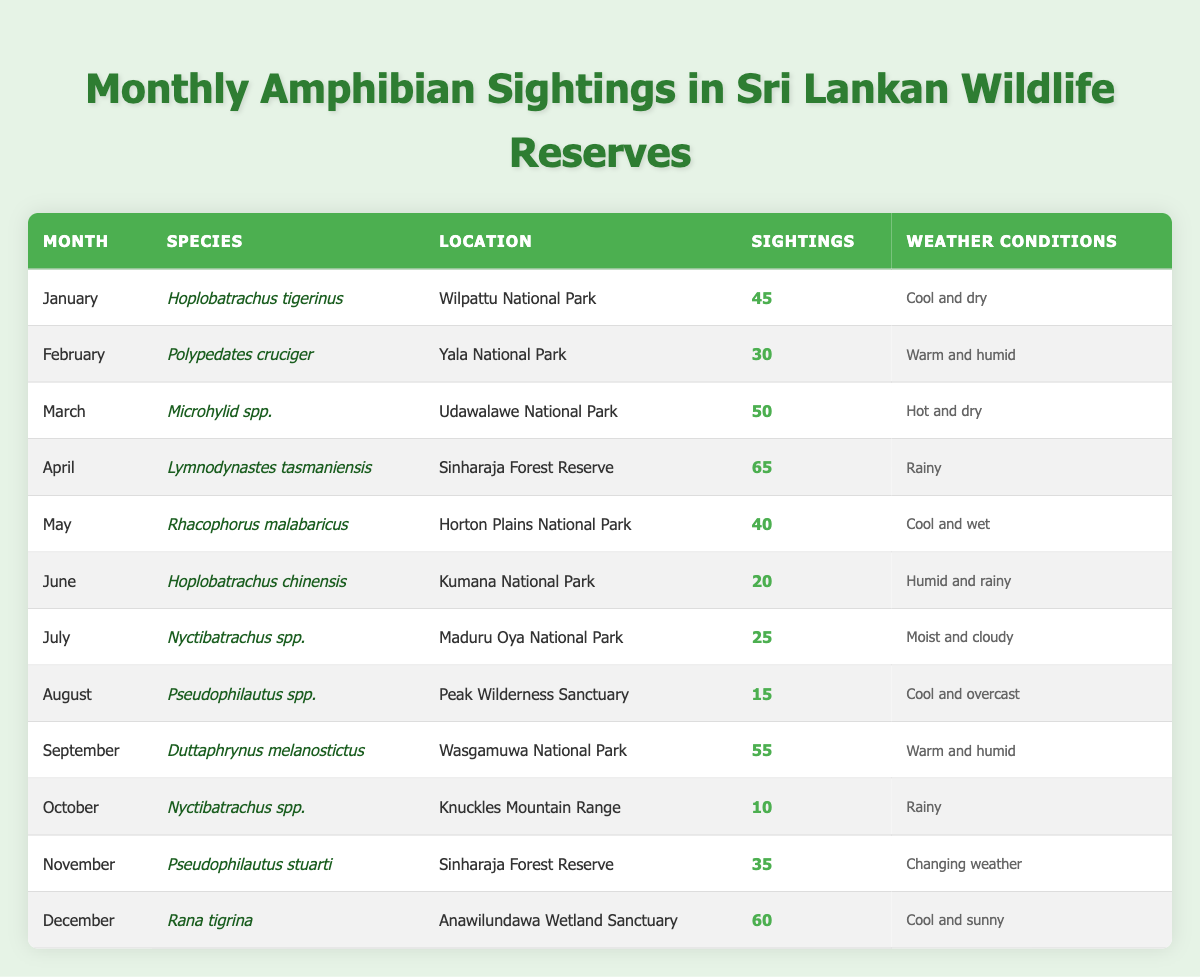What species had the highest number of sightings in April? In April, the species listed is Lymnodynastes tasmaniensis, and the sightings count is 65, which is the highest compared to other months.
Answer: Lymnodynastes tasmaniensis How many amphibians were sighted in November compared to December? In November, there were 35 sightings, while in December, there were 60 sightings. The difference is 60 - 35 = 25.
Answer: December had 25 more sightings than November Which month had the lowest amphibian sightings? The month with the lowest sightings is October, with only 10 sightings for Nyctibatrachus spp.
Answer: October What is the total number of amphibian sightings from January to March? January has 45 sightings, February has 30, and March has 50. The total is 45 + 30 + 50 = 125.
Answer: 125 Is it true that the sightings in Sunny weather conditions were higher than in Humid weather conditions? December (cool and sunny) had 60 sightings, while June (humid and rainy) had 20 sightings. Thus, yes, sightings in sunny conditions were higher.
Answer: Yes What is the average number of sightings for amphibians in the Sinharaja Forest Reserve? There are two entries for Sinharaja Forest Reserve: April with 65 sightings and November with 35 sightings. The average is (65 + 35) / 2 = 50.
Answer: 50 In which month did the sightings exceed 50, and how many total sightings were there in these months? In April (65), March (50), and September (55), all exceed 50. The total is 65 + 50 + 55 = 170.
Answer: 170 What is the weather condition in the month with the highest amphibian sightings? The highest sightings occurred in April with 65 sightings, and the weather condition is rainy.
Answer: Rainy Which species had sightings in both humid conditions, and how many total sightings were there for those months? The species in June (20 sightings) and February (30 sightings) had humid conditions. Total sightings are 20 + 30 = 50.
Answer: 50 